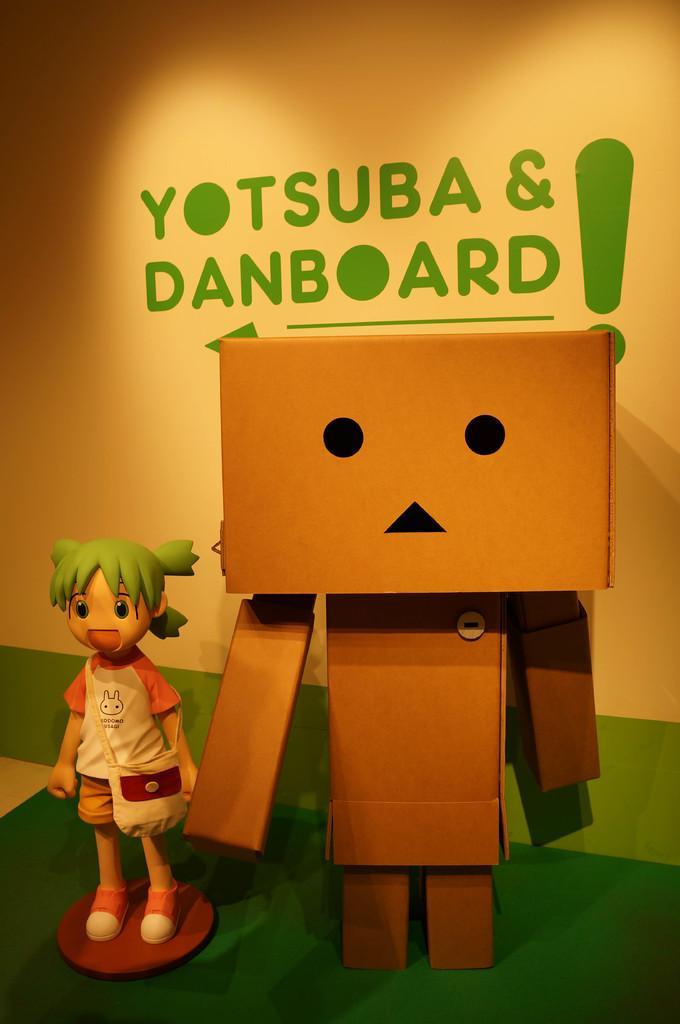In one or two sentences, can you explain what this image depicts? In this image I can see toys of a person and other thing. These objects are on a green color surface. In the background I can see a wall which has something written in green color. 